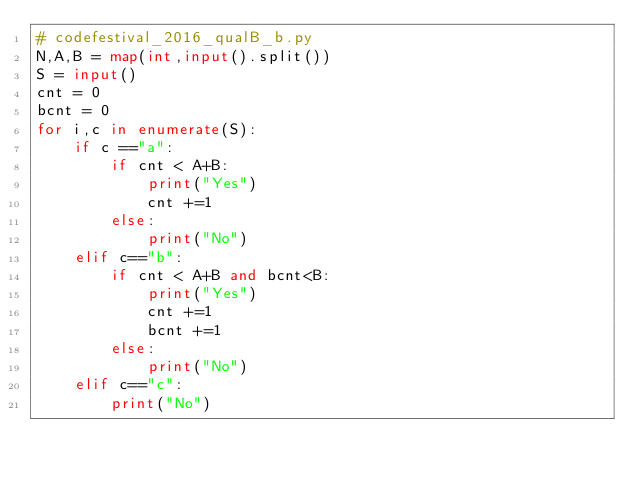<code> <loc_0><loc_0><loc_500><loc_500><_Python_># codefestival_2016_qualB_b.py
N,A,B = map(int,input().split())
S = input()
cnt = 0
bcnt = 0
for i,c in enumerate(S):
    if c =="a":
        if cnt < A+B:
            print("Yes")
            cnt +=1
        else:
            print("No")
    elif c=="b":
        if cnt < A+B and bcnt<B:
            print("Yes")
            cnt +=1
            bcnt +=1
        else:
            print("No")
    elif c=="c":
        print("No")</code> 